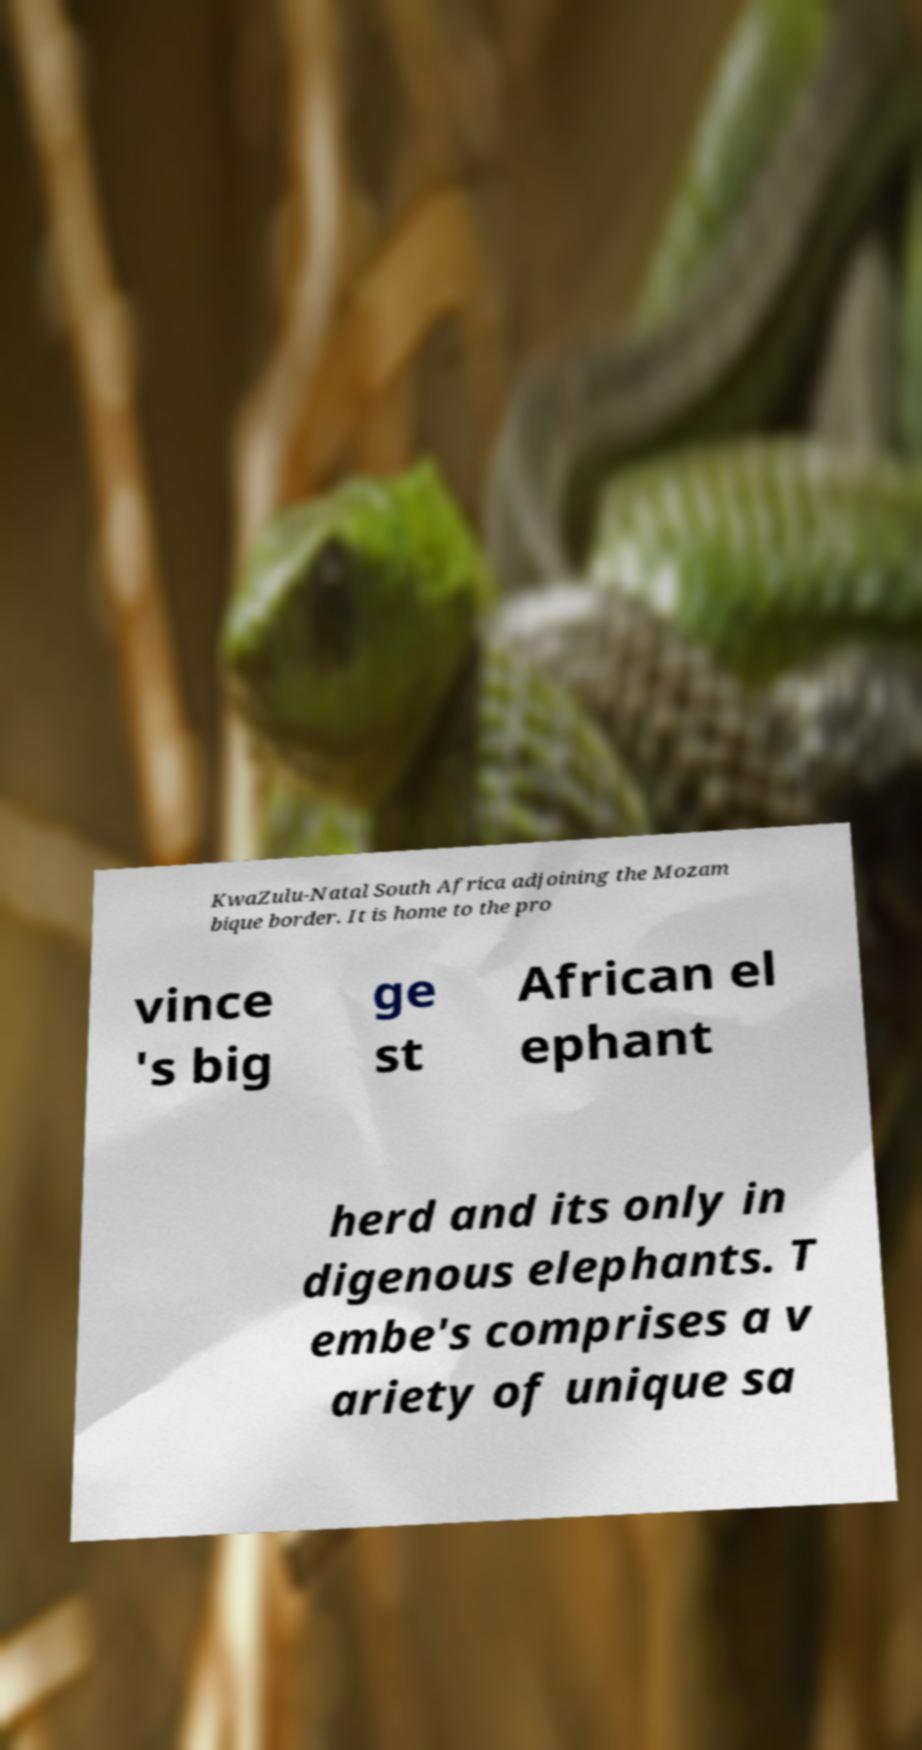What messages or text are displayed in this image? I need them in a readable, typed format. KwaZulu-Natal South Africa adjoining the Mozam bique border. It is home to the pro vince 's big ge st African el ephant herd and its only in digenous elephants. T embe's comprises a v ariety of unique sa 